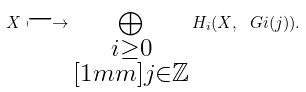Convert formula to latex. <formula><loc_0><loc_0><loc_500><loc_500>X \longmapsto \bigoplus _ { \substack { i \geq 0 \\ [ 1 m m ] j \in \mathbb { Z } } } H _ { i } ( X , \ G i ( j ) ) .</formula> 